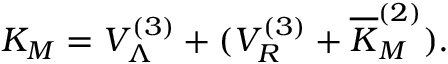Convert formula to latex. <formula><loc_0><loc_0><loc_500><loc_500>K _ { M } = V _ { \Lambda } ^ { ( 3 ) } + ( V _ { R } ^ { ( 3 ) } + \overline { K } _ { M } ^ { ( 2 ) } ) .</formula> 